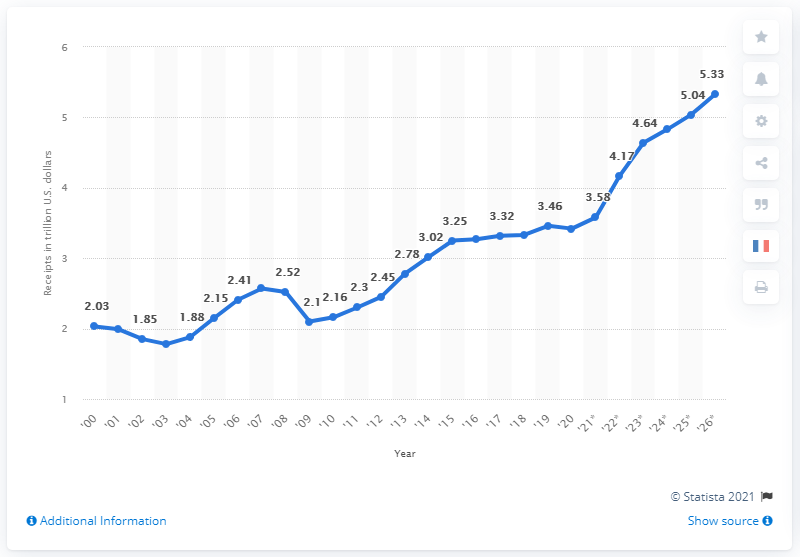Identify some key points in this picture. The total receipts of the U.S. government in 2020 were 3.42 trillion dollars. By 2026, the total receipts of the U.S. government are expected to increase to approximately $5.33 trillion. 